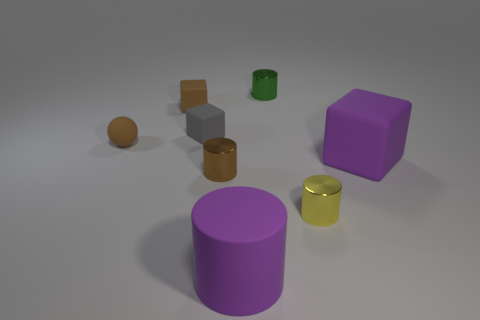There is a matte object on the right side of the matte cylinder; what shape is it?
Provide a short and direct response. Cube. There is a tiny brown object that is behind the tiny rubber block that is on the right side of the brown matte thing that is behind the tiny brown sphere; what is it made of?
Make the answer very short. Rubber. What number of other things are the same size as the green cylinder?
Make the answer very short. 5. There is a tiny green object that is the same shape as the yellow object; what is its material?
Provide a short and direct response. Metal. The rubber cylinder is what color?
Your answer should be compact. Purple. There is a large object in front of the large block that is on the right side of the purple cylinder; what color is it?
Keep it short and to the point. Purple. Do the big matte cylinder and the rubber object that is on the right side of the green cylinder have the same color?
Make the answer very short. Yes. How many tiny brown shiny things are behind the tiny shiny cylinder that is on the left side of the rubber cylinder that is in front of the tiny matte sphere?
Provide a succinct answer. 0. There is a green cylinder; are there any gray matte things behind it?
Offer a very short reply. No. Are there any other things that have the same color as the large rubber block?
Your answer should be compact. Yes. 